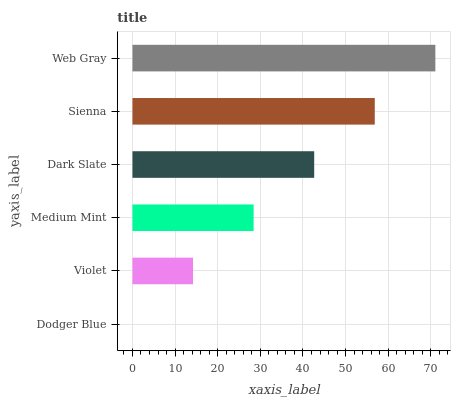Is Dodger Blue the minimum?
Answer yes or no. Yes. Is Web Gray the maximum?
Answer yes or no. Yes. Is Violet the minimum?
Answer yes or no. No. Is Violet the maximum?
Answer yes or no. No. Is Violet greater than Dodger Blue?
Answer yes or no. Yes. Is Dodger Blue less than Violet?
Answer yes or no. Yes. Is Dodger Blue greater than Violet?
Answer yes or no. No. Is Violet less than Dodger Blue?
Answer yes or no. No. Is Dark Slate the high median?
Answer yes or no. Yes. Is Medium Mint the low median?
Answer yes or no. Yes. Is Sienna the high median?
Answer yes or no. No. Is Web Gray the low median?
Answer yes or no. No. 